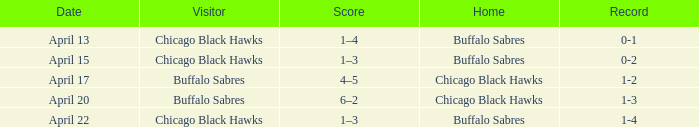Which residence is on april 22? Buffalo Sabres. 